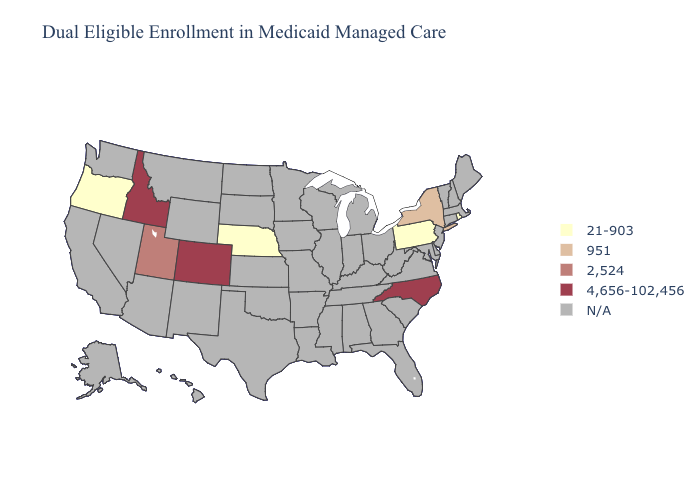Name the states that have a value in the range 2,524?
Answer briefly. Utah. Is the legend a continuous bar?
Be succinct. No. Does New York have the highest value in the Northeast?
Concise answer only. Yes. What is the lowest value in the West?
Short answer required. 21-903. Among the states that border Oklahoma , which have the highest value?
Answer briefly. Colorado. Name the states that have a value in the range 4,656-102,456?
Concise answer only. Colorado, Idaho, North Carolina. What is the highest value in the USA?
Answer briefly. 4,656-102,456. What is the value of Florida?
Keep it brief. N/A. Which states hav the highest value in the South?
Be succinct. North Carolina. 